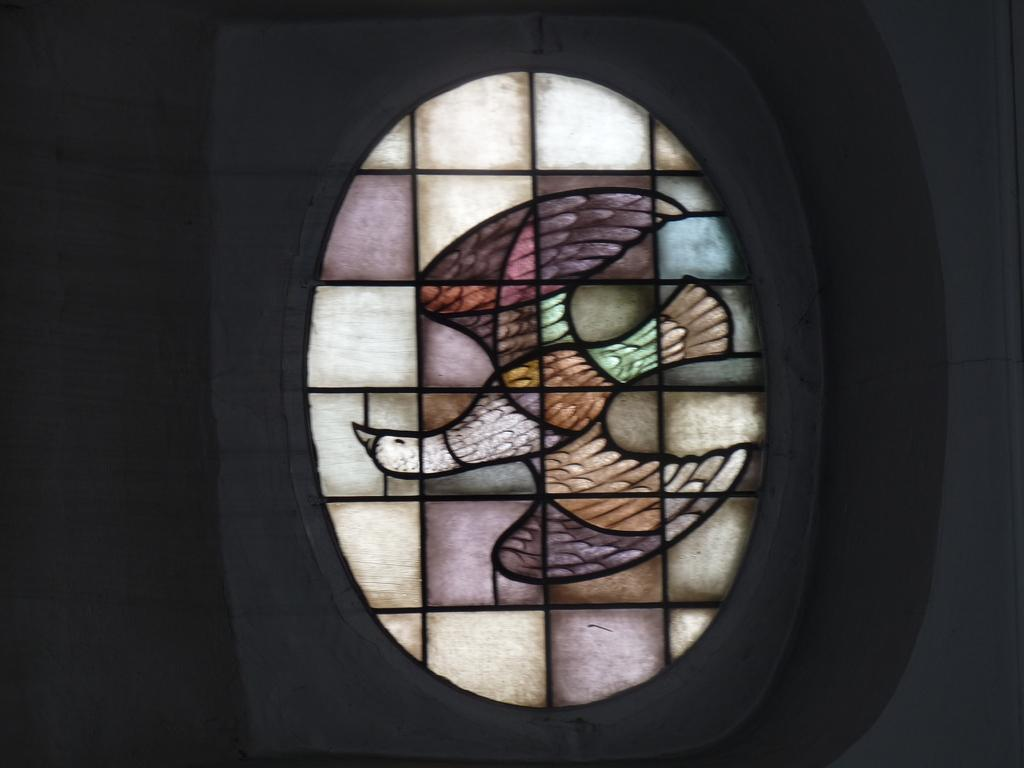What can be seen in the image that provides a view or access to the outdoors? There is a window in the image. What is depicted on the window? The window has a picture of a bird. What else is visible in the image besides the window? There is a wall visible in the image. Can you tell me how many berries are on the giraffe in the image? There is no giraffe or berries present in the image. 